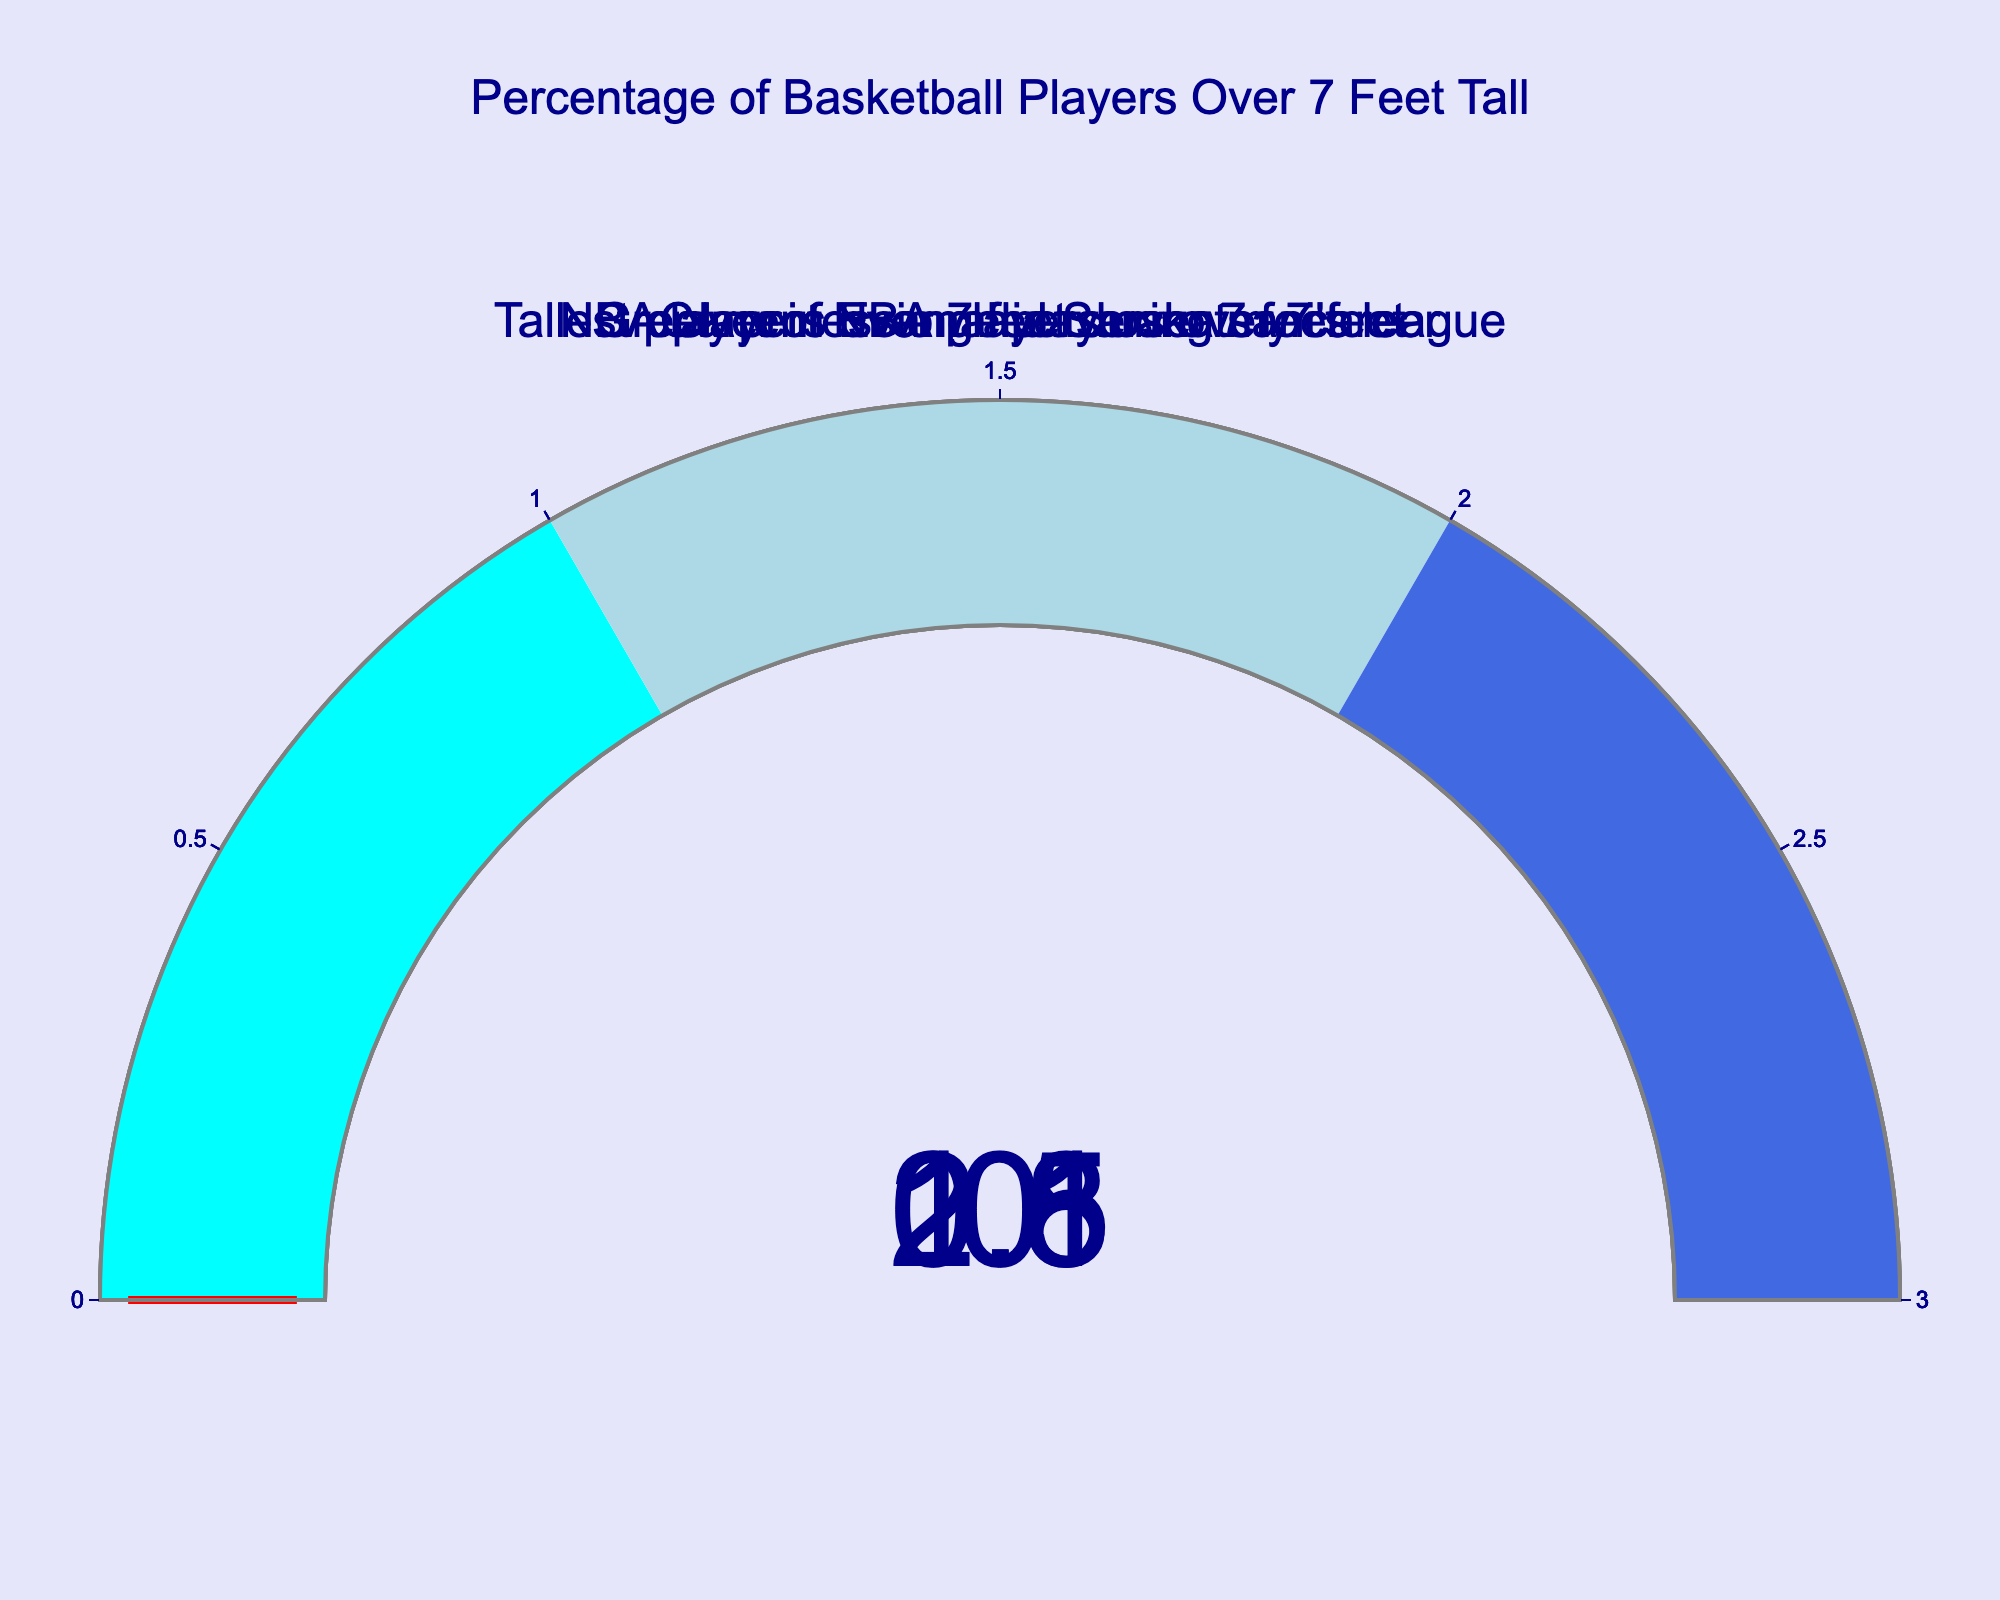What is the current percentage of NBA players over 7 feet tall? The gauge chart shows the value corresponding to "Current NBA players over 7 feet" as 2.1%.
Answer: 2.1% How much more percentage of current NBA players are over 7 feet tall compared to during your career? The value for current NBA players over 7 feet is 2.1%, and for NBA players during your career is 1.8%. The difference is 2.1% - 1.8% = 0.3%.
Answer: 0.3% What is the average percentage of NBA players over 7 feet tall currently and during your career? The value for current NBA players is 2.1% and during your career is 1.8%. The average is (2.1% + 1.8%) / 2 = 1.95%.
Answer: 1.95% Which group has the lowest percentage of players over 7 feet tall? Among the provided groups, "Tallest player in Evangelia Sarakatsani's league" has the lowest percentage of 0.0%.
Answer: Tallest player in Evangelia Sarakatsani's league How does the percentage of Greek professional players over 7 feet compare to the percentage of NBA players over 7 feet tall during your career? The percentage of Greek professional players over 7 feet is 0.5%, while the percentage during your career is 1.8%. 0.5% is less than 1.8%.
Answer: Greek professional players less By what factor do current NBA players over 7 feet tall exceed Greek professional players over 7 feet tall? The percentage of current NBA players over 7 feet is 2.1% and Greek professional players is 0.5%. The factor is 2.1 / 0.5 = 4.2.
Answer: 4.2 Has any player in Evangelia Sarakatsani's league passed the 7 feet mark? The gauge for "Tallest player in Evangelia Sarakatsani's league" shows 0.0%, which means no player has passed the 7 feet mark.
Answer: No Calculate the percentage point increase in NBA players over 7 feet from your career to now. The percentage during your career was 1.8%, and it is 2.1% now. The increase in percentage points is 2.1% - 1.8% = 0.3%.
Answer: 0.3% What is the combined percentage of NBA and Greek professional players over 7 feet during your career? The percentage of NBA players during your career is 1.8% and Greek professional players is 0.5%. The combined percentage is 1.8% + 0.5% = 2.3%.
Answer: 2.3% 